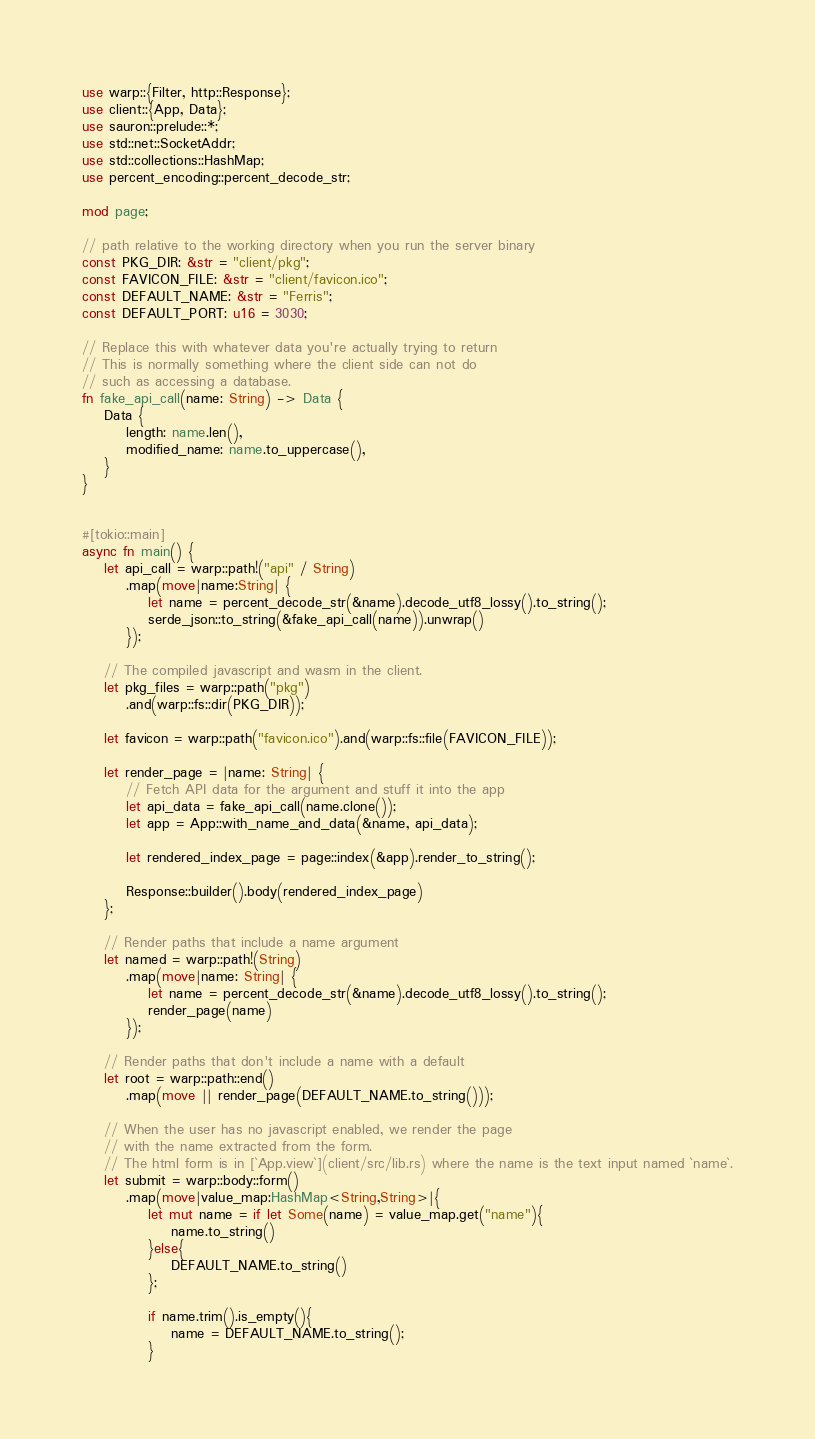Convert code to text. <code><loc_0><loc_0><loc_500><loc_500><_Rust_>use warp::{Filter, http::Response};
use client::{App, Data};
use sauron::prelude::*;
use std::net::SocketAddr;
use std::collections::HashMap;
use percent_encoding::percent_decode_str;

mod page;

// path relative to the working directory when you run the server binary
const PKG_DIR: &str = "client/pkg";
const FAVICON_FILE: &str = "client/favicon.ico";
const DEFAULT_NAME: &str = "Ferris";
const DEFAULT_PORT: u16 = 3030;

// Replace this with whatever data you're actually trying to return
// This is normally something where the client side can not do
// such as accessing a database.
fn fake_api_call(name: String) -> Data {
    Data {
        length: name.len(),
        modified_name: name.to_uppercase(),
    }
}


#[tokio::main]
async fn main() {
    let api_call = warp::path!("api" / String)
        .map(move|name:String| {
            let name = percent_decode_str(&name).decode_utf8_lossy().to_string();
            serde_json::to_string(&fake_api_call(name)).unwrap()
        });

    // The compiled javascript and wasm in the client.
    let pkg_files = warp::path("pkg")
        .and(warp::fs::dir(PKG_DIR));

    let favicon = warp::path("favicon.ico").and(warp::fs::file(FAVICON_FILE));

    let render_page = |name: String| {
        // Fetch API data for the argument and stuff it into the app
        let api_data = fake_api_call(name.clone());
        let app = App::with_name_and_data(&name, api_data);

        let rendered_index_page = page::index(&app).render_to_string();

        Response::builder().body(rendered_index_page)
    };

    // Render paths that include a name argument
    let named = warp::path!(String)
        .map(move|name: String| {
            let name = percent_decode_str(&name).decode_utf8_lossy().to_string();
            render_page(name)
        });

    // Render paths that don't include a name with a default
    let root = warp::path::end()
        .map(move || render_page(DEFAULT_NAME.to_string()));

    // When the user has no javascript enabled, we render the page
    // with the name extracted from the form.
    // The html form is in [`App.view`](client/src/lib.rs) where the name is the text input named `name`.
    let submit = warp::body::form()
        .map(move|value_map:HashMap<String,String>|{
            let mut name = if let Some(name) = value_map.get("name"){
                name.to_string()
            }else{
                DEFAULT_NAME.to_string()
            };

            if name.trim().is_empty(){
                name = DEFAULT_NAME.to_string();
            }</code> 